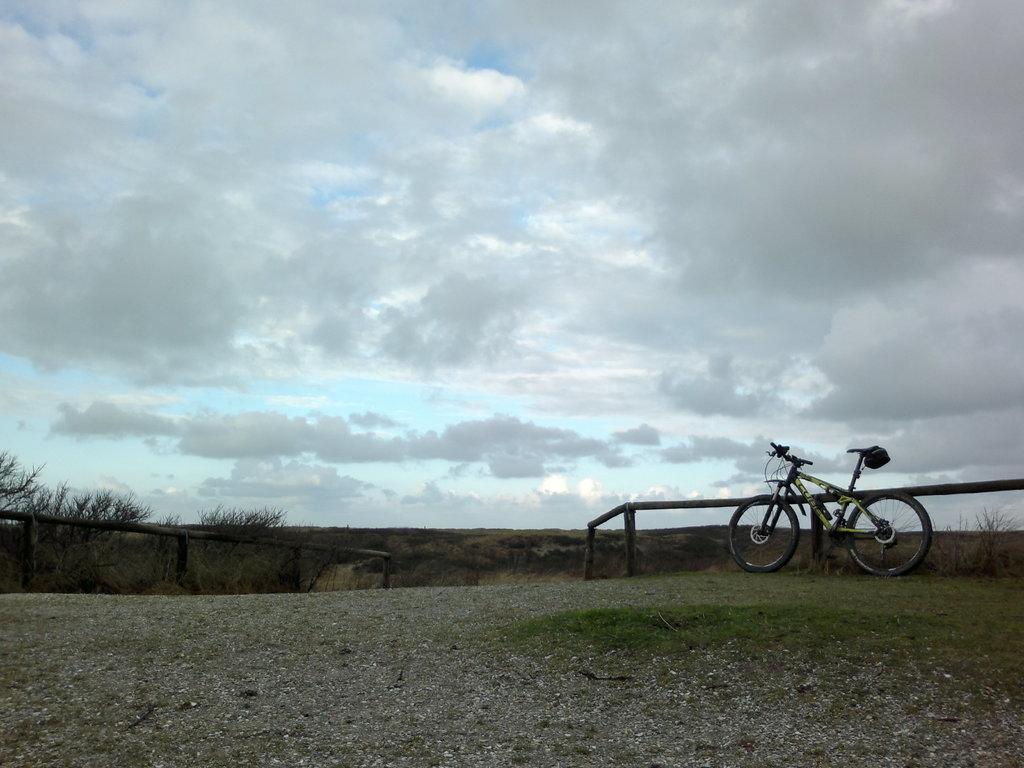In one or two sentences, can you explain what this image depicts? On both right and left side of the image there is a wooden fence. On the right side of the image there is a cycle. In the background of the image there are trees and sky. 